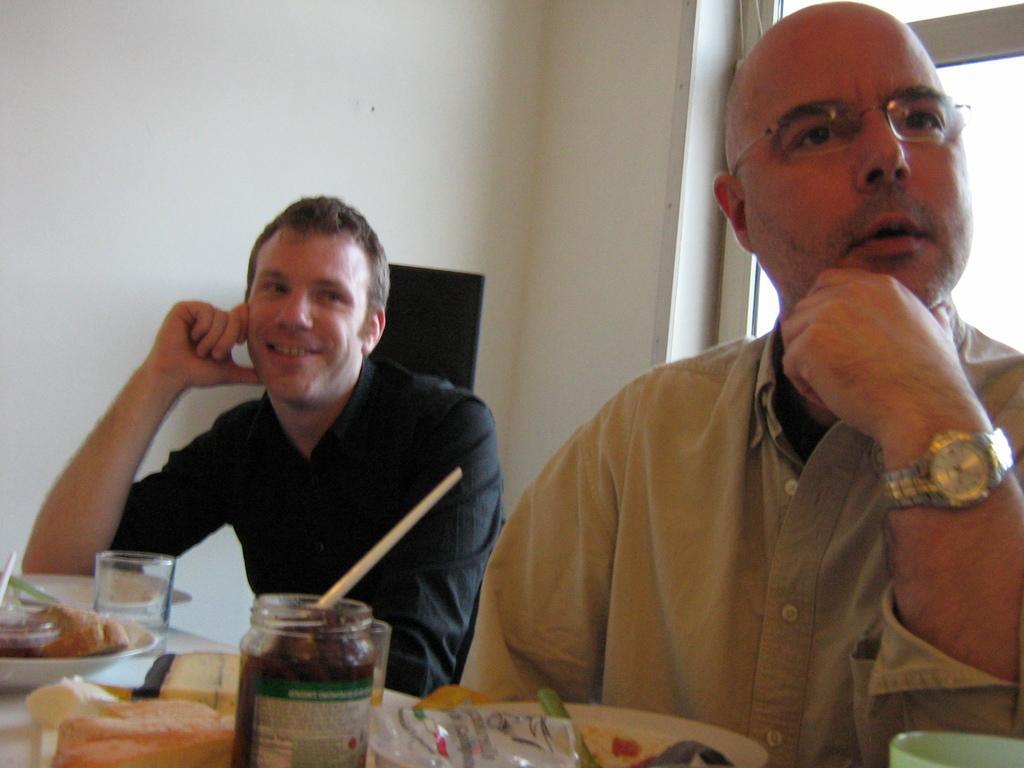Describe this image in one or two sentences. In this image I can see two people sitting in-front of the table. These people are wearing the different color dresses and I can see one person with the specs. On the table I can see the plates and bowls with the food. To the side there is a glass and container. In the background I can see the window and the wall. 